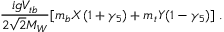Convert formula to latex. <formula><loc_0><loc_0><loc_500><loc_500>{ \frac { i g V _ { t b } } { 2 \sqrt { 2 } M _ { W } } } [ m _ { b } X ( 1 + { \gamma } _ { 5 } ) + m _ { t } Y ( 1 - { \gamma } _ { 5 } ) ] \, .</formula> 